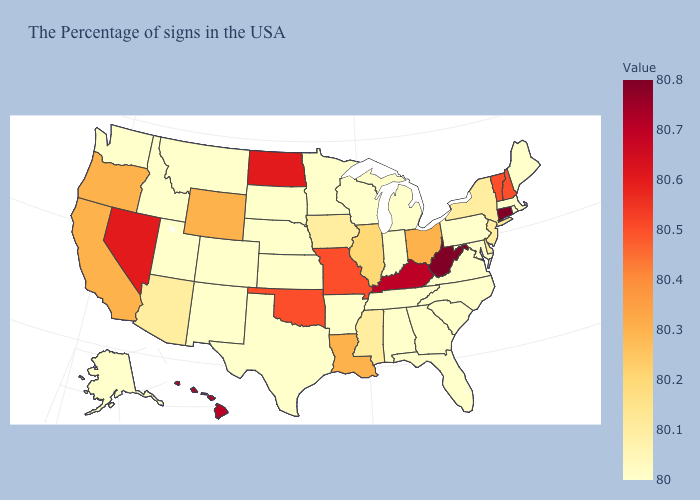Does South Carolina have a lower value than California?
Quick response, please. Yes. Does Massachusetts have a lower value than Iowa?
Keep it brief. Yes. Does Colorado have the highest value in the USA?
Keep it brief. No. Which states have the lowest value in the MidWest?
Concise answer only. Michigan, Indiana, Wisconsin, Minnesota, Kansas, Nebraska, South Dakota. 